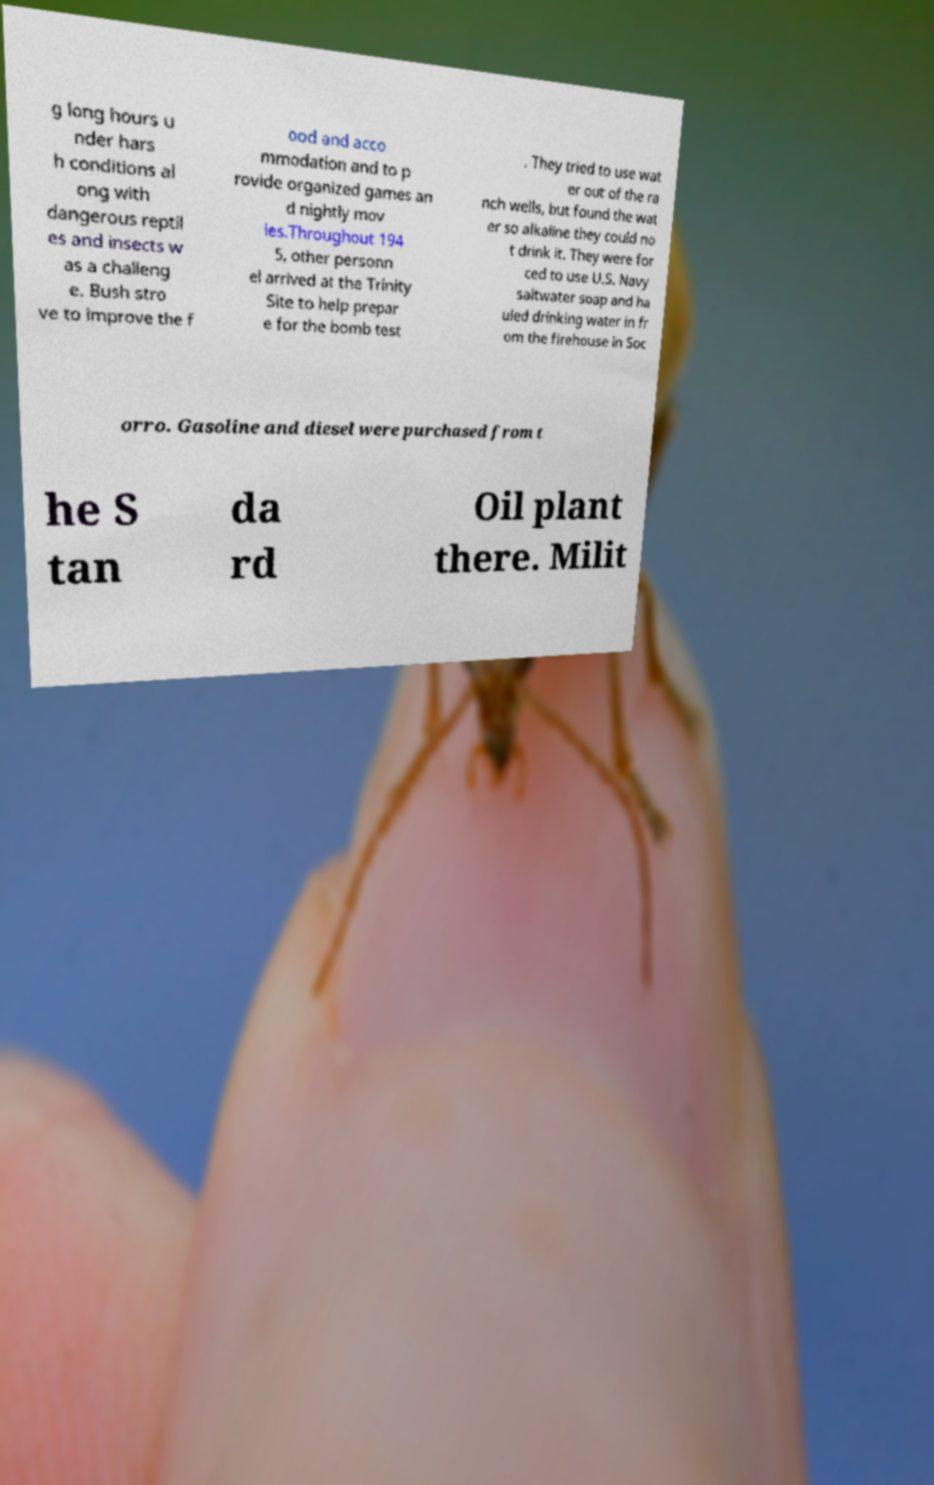Please identify and transcribe the text found in this image. g long hours u nder hars h conditions al ong with dangerous reptil es and insects w as a challeng e. Bush stro ve to improve the f ood and acco mmodation and to p rovide organized games an d nightly mov ies.Throughout 194 5, other personn el arrived at the Trinity Site to help prepar e for the bomb test . They tried to use wat er out of the ra nch wells, but found the wat er so alkaline they could no t drink it. They were for ced to use U.S. Navy saltwater soap and ha uled drinking water in fr om the firehouse in Soc orro. Gasoline and diesel were purchased from t he S tan da rd Oil plant there. Milit 